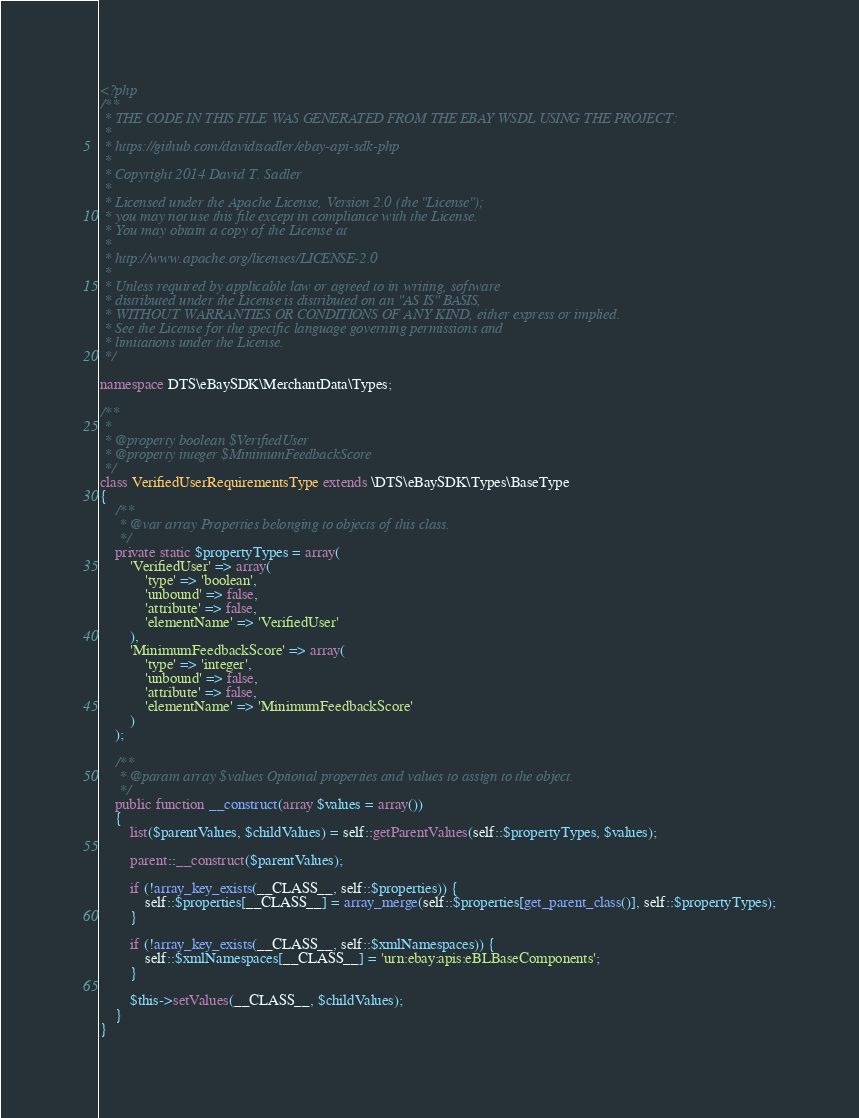<code> <loc_0><loc_0><loc_500><loc_500><_PHP_><?php
/**
 * THE CODE IN THIS FILE WAS GENERATED FROM THE EBAY WSDL USING THE PROJECT:
 *
 * https://github.com/davidtsadler/ebay-api-sdk-php
 *
 * Copyright 2014 David T. Sadler
 *
 * Licensed under the Apache License, Version 2.0 (the "License");
 * you may not use this file except in compliance with the License.
 * You may obtain a copy of the License at
 *
 * http://www.apache.org/licenses/LICENSE-2.0
 *
 * Unless required by applicable law or agreed to in writing, software
 * distributed under the License is distributed on an "AS IS" BASIS,
 * WITHOUT WARRANTIES OR CONDITIONS OF ANY KIND, either express or implied.
 * See the License for the specific language governing permissions and
 * limitations under the License.
 */

namespace DTS\eBaySDK\MerchantData\Types;

/**
 *
 * @property boolean $VerifiedUser
 * @property integer $MinimumFeedbackScore
 */
class VerifiedUserRequirementsType extends \DTS\eBaySDK\Types\BaseType
{
    /**
     * @var array Properties belonging to objects of this class.
     */
    private static $propertyTypes = array(
        'VerifiedUser' => array(
            'type' => 'boolean',
            'unbound' => false,
            'attribute' => false,
            'elementName' => 'VerifiedUser'
        ),
        'MinimumFeedbackScore' => array(
            'type' => 'integer',
            'unbound' => false,
            'attribute' => false,
            'elementName' => 'MinimumFeedbackScore'
        )
    );

    /**
     * @param array $values Optional properties and values to assign to the object.
     */
    public function __construct(array $values = array())
    {
        list($parentValues, $childValues) = self::getParentValues(self::$propertyTypes, $values);

        parent::__construct($parentValues);

        if (!array_key_exists(__CLASS__, self::$properties)) {
            self::$properties[__CLASS__] = array_merge(self::$properties[get_parent_class()], self::$propertyTypes);
        }

        if (!array_key_exists(__CLASS__, self::$xmlNamespaces)) {
            self::$xmlNamespaces[__CLASS__] = 'urn:ebay:apis:eBLBaseComponents';
        }

        $this->setValues(__CLASS__, $childValues);
    }
}
</code> 